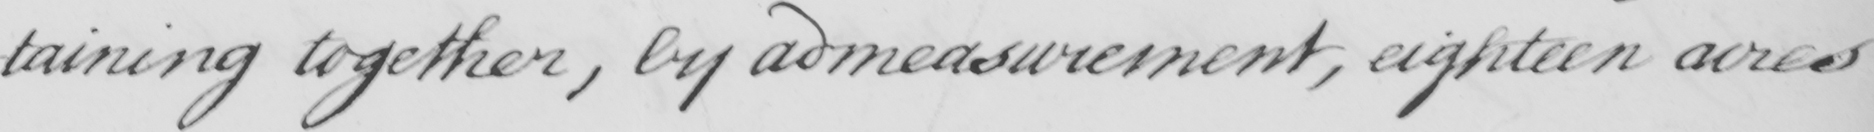What does this handwritten line say? -taining together , by admeasurement  , eighteen acres 